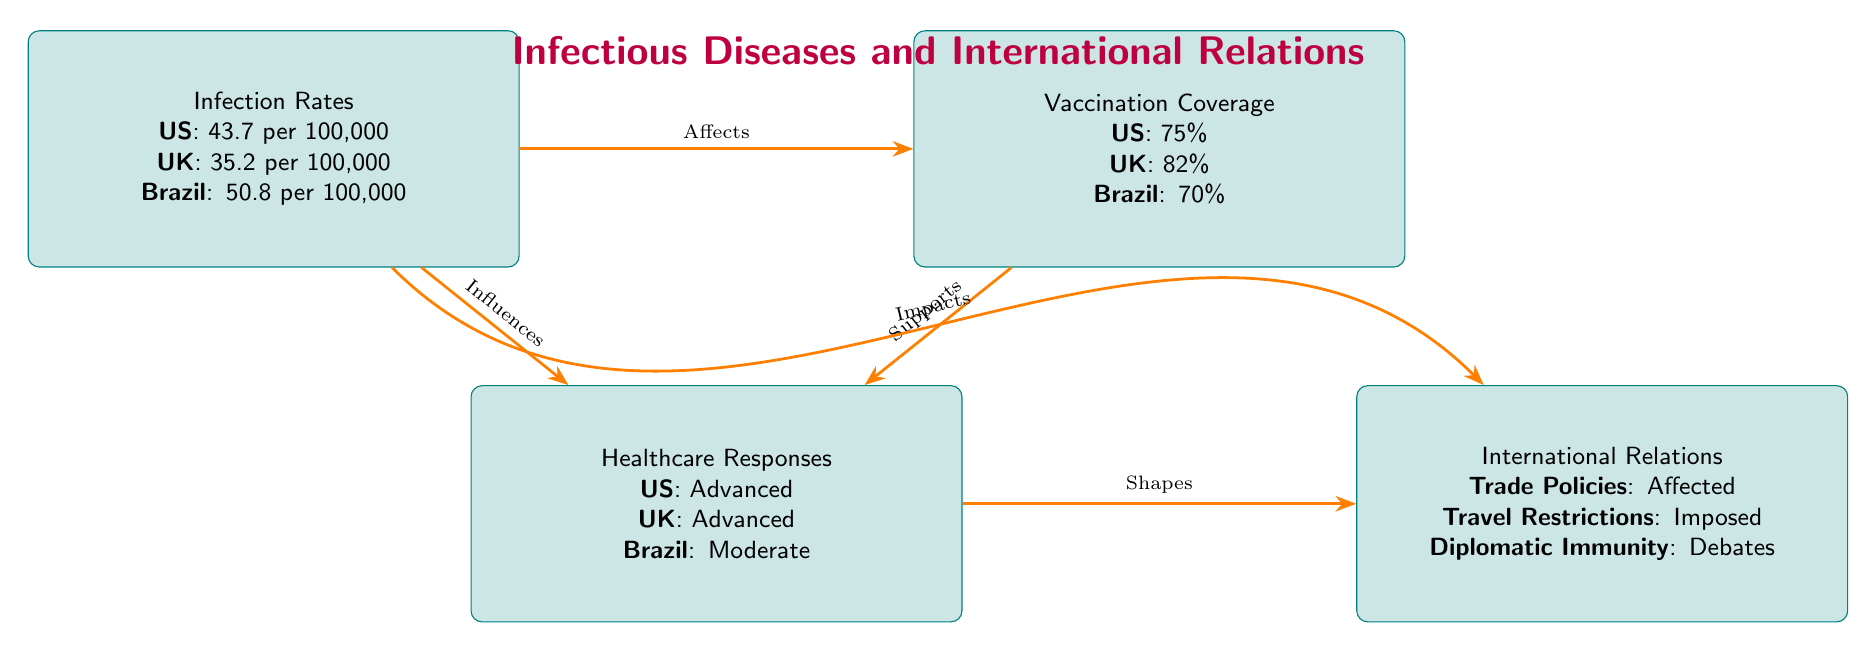What is the infection rate in the US? The infection rate for the US is explicitly mentioned in the 'Infection Rates' node of the diagram, which states "US: 43.7 per 100,000".
Answer: 43.7 per 100,000 What is the vaccination coverage in the UK? The 'Vaccination Coverage' node provides the vaccination percentage for the UK, which is specified as "UK: 82%".
Answer: 82% How are healthcare responses categorized for Brazil? The 'Healthcare Responses' node lists Brazil's response as "Moderate," which is directly stated in the diagram.
Answer: Moderate How does infection rate influence vaccination coverage? The diagram shows an arrow from 'Infection Rates' to 'Vaccination Coverage' labeled "Affects," indicating a direct influence relationship based on the flow of information.
Answer: Affects Which country has an advanced healthcare response? The 'Healthcare Responses' node lists both the US and the UK as having "Advanced" healthcare responses, but we need to specify one country mentioned.
Answer: US or UK What international relation aspect is affected by infection rates? The diagram indicates that 'Infection Rates' impacts 'International Relations' with an arrow labeled "Impacts," suggesting a direct effect on international policies or agreements.
Answer: International Relations What does vaccination coverage support in the diagram? The diagram shows an arrow leading from 'Vaccination Coverage' to 'Healthcare Responses' labeled "Supports," indicating that vaccination coverage positively contributes to the healthcare responses.
Answer: Healthcare Responses What type of healthcare response is characterized for the US? In the 'Healthcare Responses' node, the US is specifically categorized as having "Advanced" healthcare services, as defined in the diagram.
Answer: Advanced What does the relationship between healthcare responses and international relations indicate? An arrow labeled "Shapes" from 'Healthcare Responses' to 'International Relations' in the diagram indicates that the type of healthcare response influences or determines aspects of international relations.
Answer: Shapes 